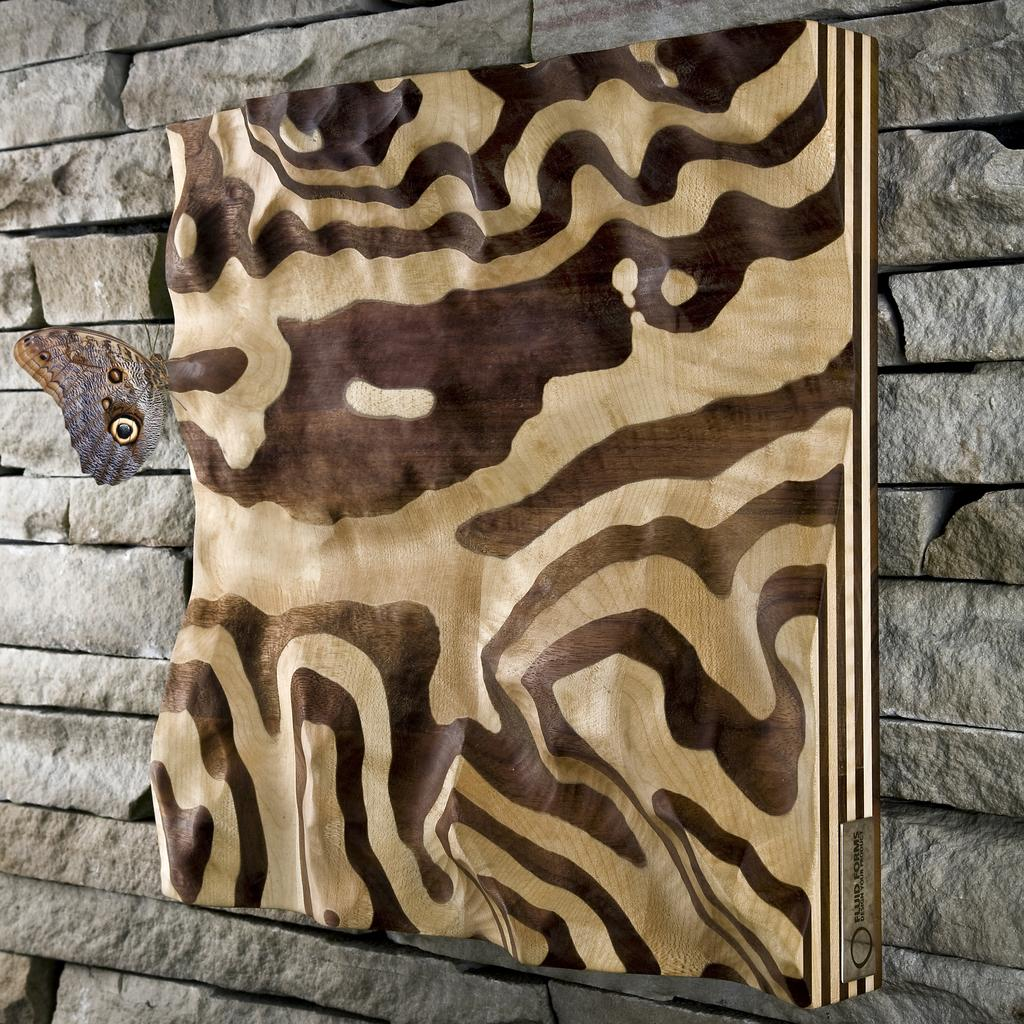What is the main object in the image? There is a frame in the image. Where is the frame located? The frame is on a stone wall. What can be seen on the left side of the image? There is a butterfly on the left side of the image. What type of nerve can be seen in the image in the image? There is no nerve present in the image; it features a frame on a stone wall and a butterfly. 